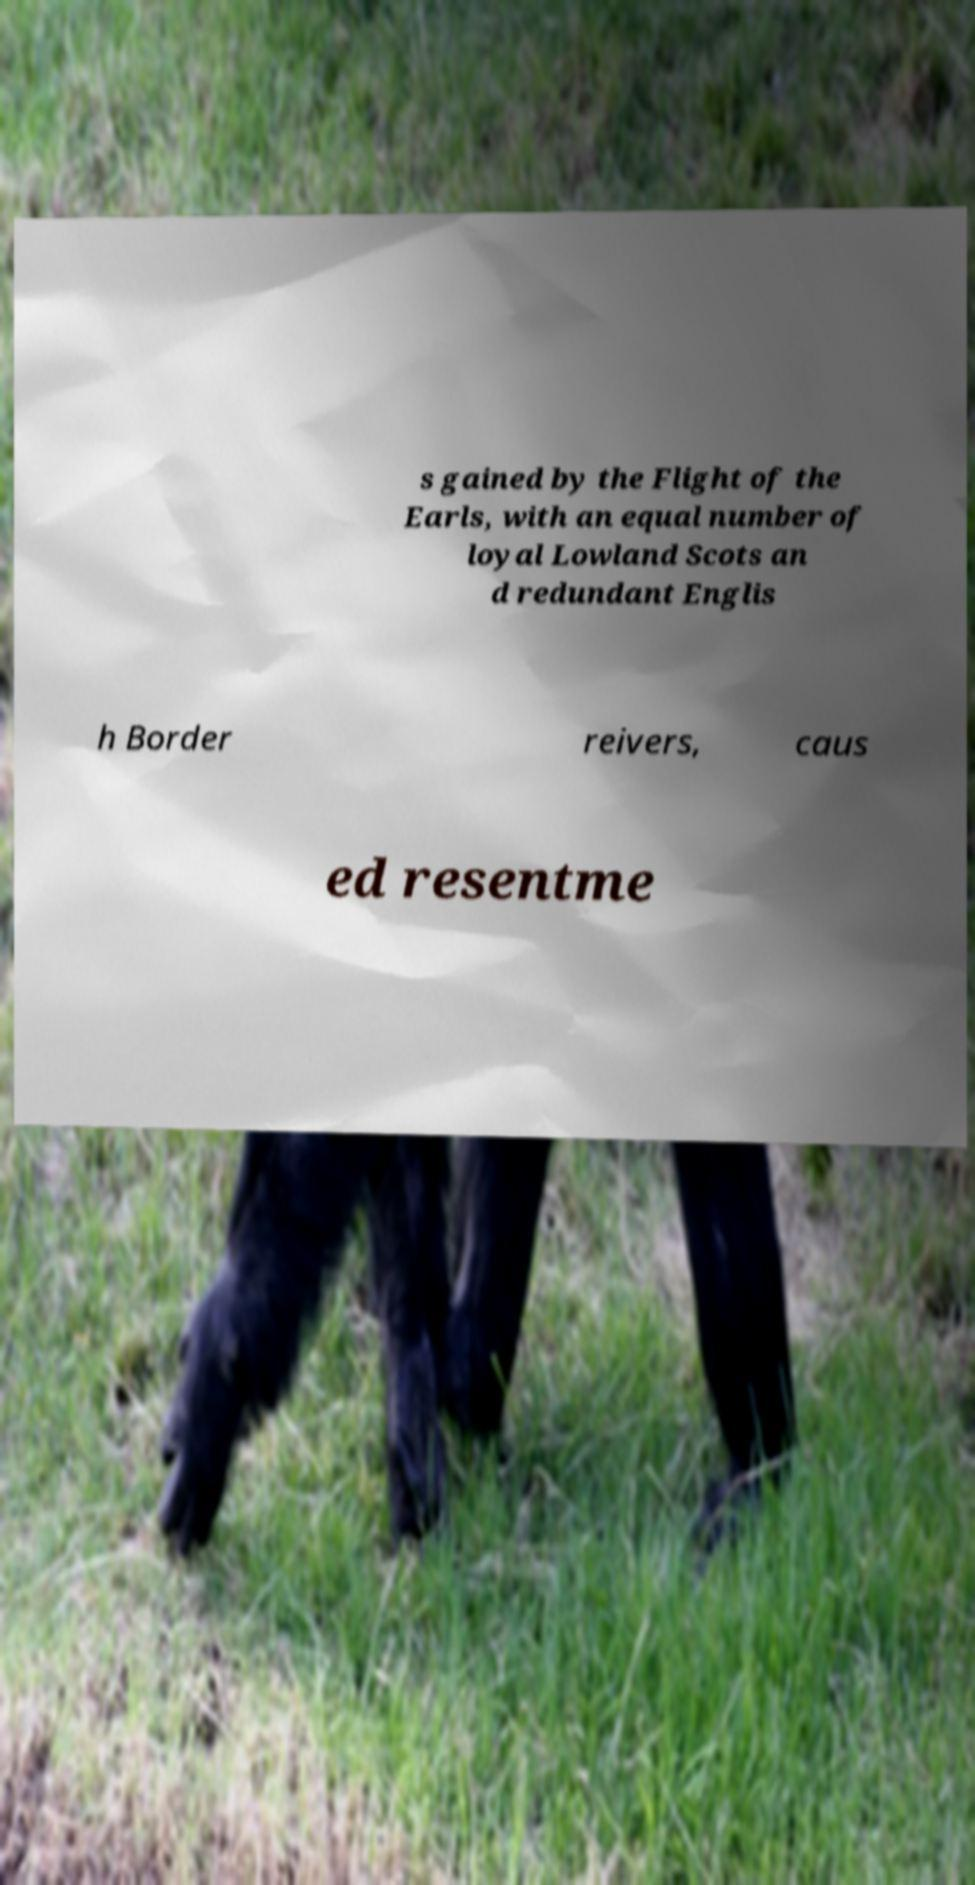Could you extract and type out the text from this image? s gained by the Flight of the Earls, with an equal number of loyal Lowland Scots an d redundant Englis h Border reivers, caus ed resentme 